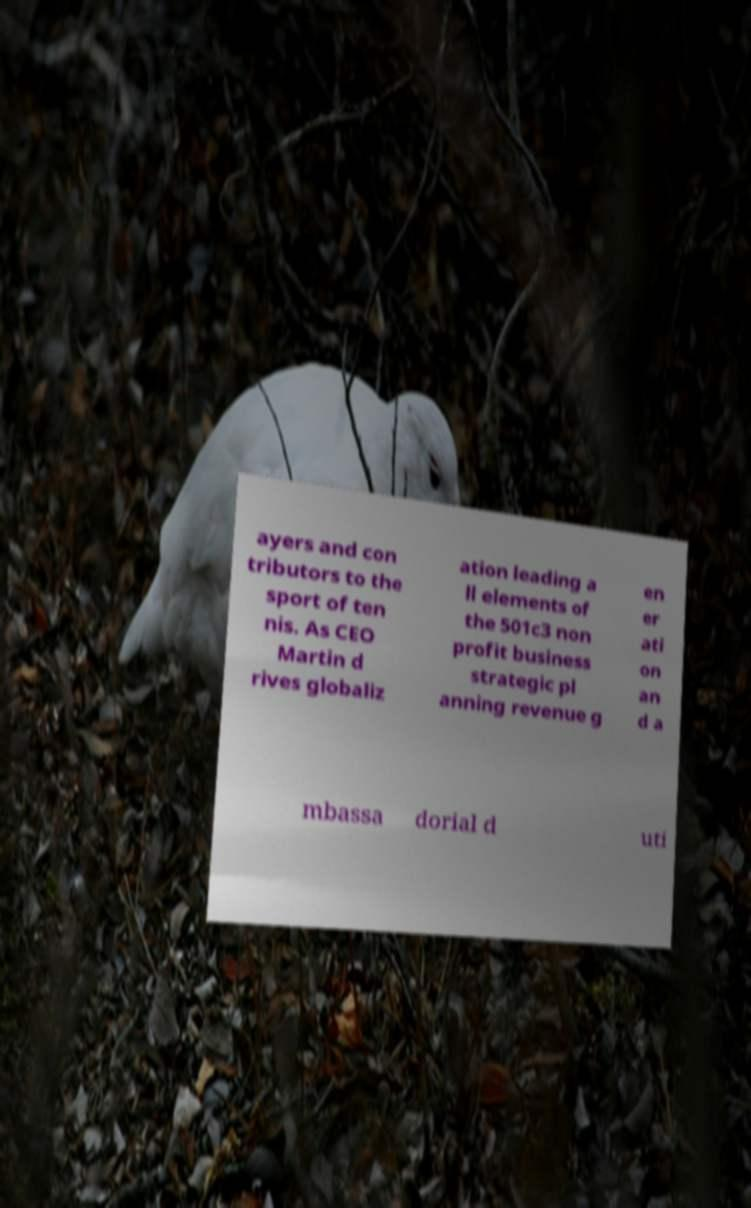For documentation purposes, I need the text within this image transcribed. Could you provide that? ayers and con tributors to the sport of ten nis. As CEO Martin d rives globaliz ation leading a ll elements of the 501c3 non profit business strategic pl anning revenue g en er ati on an d a mbassa dorial d uti 